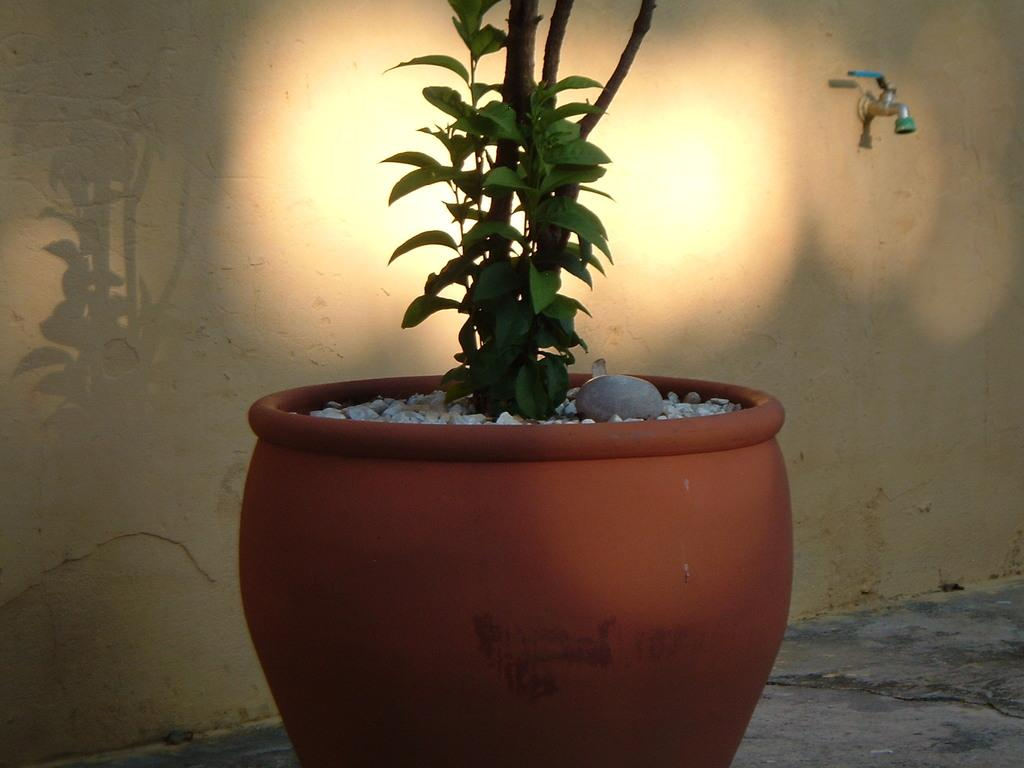What is attached to the wall in the image? There is a tap on the wall in the image. What type of plant can be seen in the image? There is a plant in a pot in the image. What color is the pot that the plant is in? The pot is brown in color. What type of material is visible in the image? There are stones visible in the image. Can you see any legs on the plant in the image? There are no legs visible on the plant in the image, as plants do not have legs. Is the plant made of plastic in the image? The plant is not made of plastic in the image; it is a real plant in a pot. 